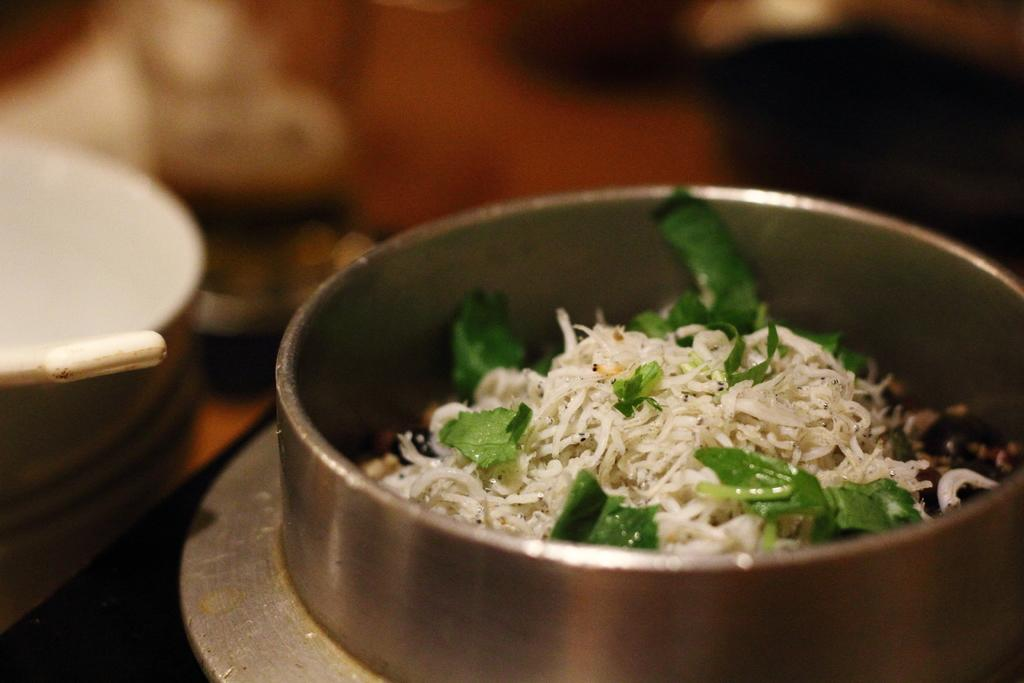What is in the container that is visible in the image? There is a container with food in the image. Can you describe the background of the image? The background of the image is blurred. Where is the giraffe in the image? There is no giraffe present in the image. What type of squirrel can be seen climbing the bucket in the image? There is no bucket or squirrel present in the image. 